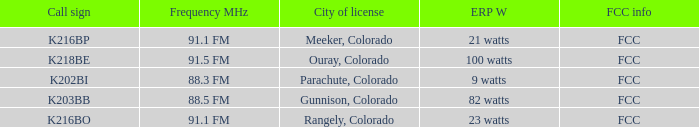Can you parse all the data within this table? {'header': ['Call sign', 'Frequency MHz', 'City of license', 'ERP W', 'FCC info'], 'rows': [['K216BP', '91.1 FM', 'Meeker, Colorado', '21 watts', 'FCC'], ['K218BE', '91.5 FM', 'Ouray, Colorado', '100 watts', 'FCC'], ['K202BI', '88.3 FM', 'Parachute, Colorado', '9 watts', 'FCC'], ['K203BB', '88.5 FM', 'Gunnison, Colorado', '82 watts', 'FCC'], ['K216BO', '91.1 FM', 'Rangely, Colorado', '23 watts', 'FCC']]} Which ERP W has a Frequency MHz of 88.5 FM? 82 watts. 